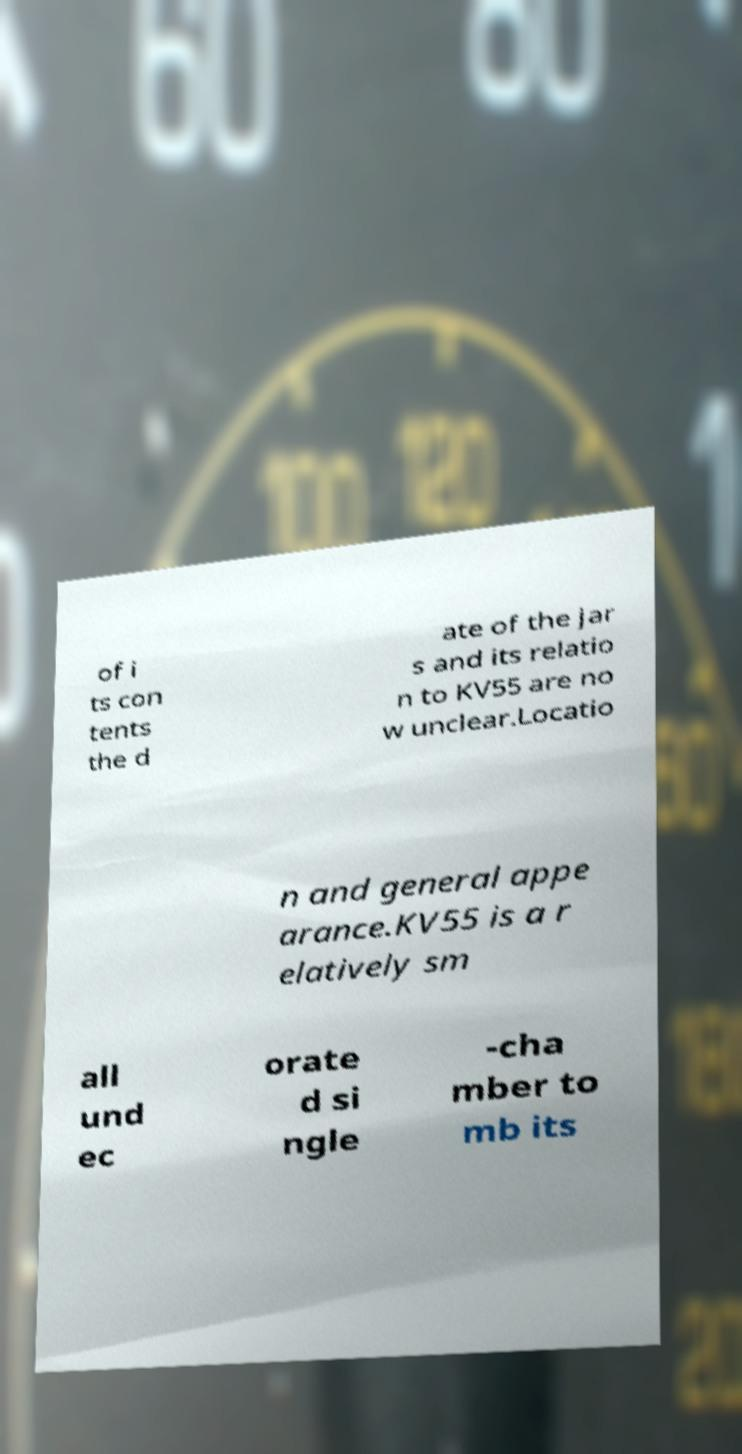There's text embedded in this image that I need extracted. Can you transcribe it verbatim? of i ts con tents the d ate of the jar s and its relatio n to KV55 are no w unclear.Locatio n and general appe arance.KV55 is a r elatively sm all und ec orate d si ngle -cha mber to mb its 